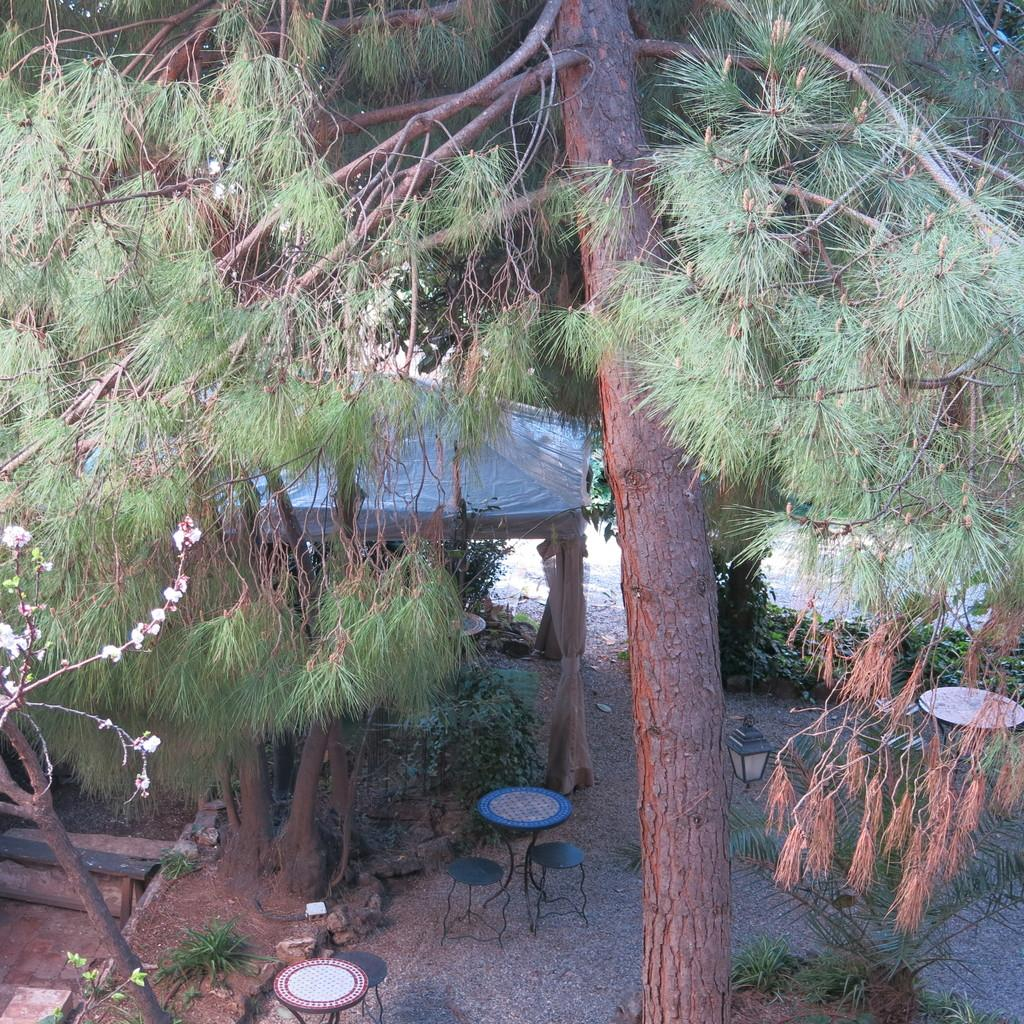What type of furniture is present in the image? There are tables and stools in the image. What type of vegetation is present in the image? There are trees in the image. What type of quiver is hanging on the tree in the image? There is no quiver present in the image; it only features tables, stools, and trees. 